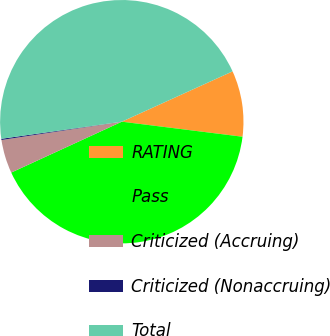<chart> <loc_0><loc_0><loc_500><loc_500><pie_chart><fcel>RATING<fcel>Pass<fcel>Criticized (Accruing)<fcel>Criticized (Nonaccruing)<fcel>Total<nl><fcel>8.76%<fcel>41.16%<fcel>4.46%<fcel>0.16%<fcel>45.46%<nl></chart> 